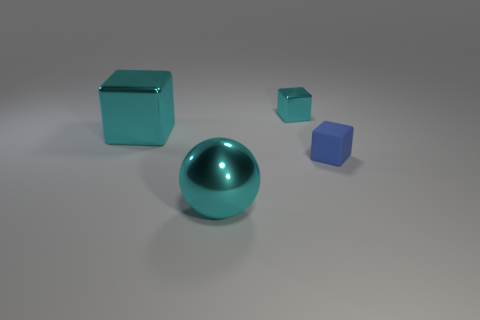Add 3 purple cubes. How many objects exist? 7 Subtract all blue matte blocks. How many blocks are left? 2 Subtract 1 cubes. How many cubes are left? 2 Subtract all cubes. How many objects are left? 1 Subtract 1 cyan spheres. How many objects are left? 3 Subtract all tiny metallic blocks. Subtract all big cyan blocks. How many objects are left? 2 Add 4 large cyan metal things. How many large cyan metal things are left? 6 Add 1 tiny blue things. How many tiny blue things exist? 2 